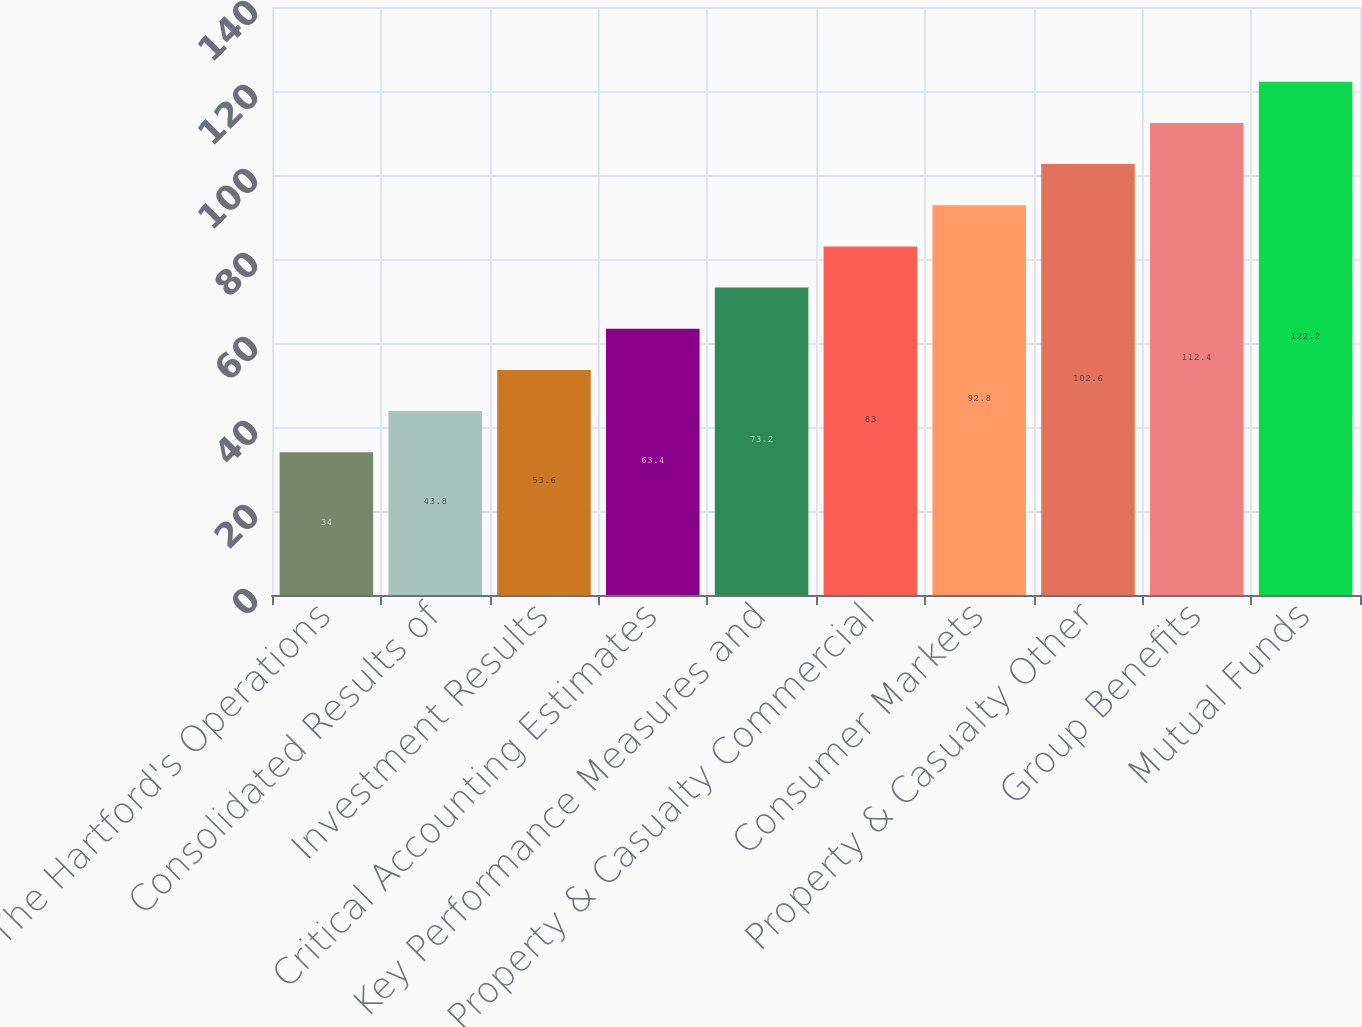Convert chart. <chart><loc_0><loc_0><loc_500><loc_500><bar_chart><fcel>The Hartford's Operations<fcel>Consolidated Results of<fcel>Investment Results<fcel>Critical Accounting Estimates<fcel>Key Performance Measures and<fcel>Property & Casualty Commercial<fcel>Consumer Markets<fcel>Property & Casualty Other<fcel>Group Benefits<fcel>Mutual Funds<nl><fcel>34<fcel>43.8<fcel>53.6<fcel>63.4<fcel>73.2<fcel>83<fcel>92.8<fcel>102.6<fcel>112.4<fcel>122.2<nl></chart> 